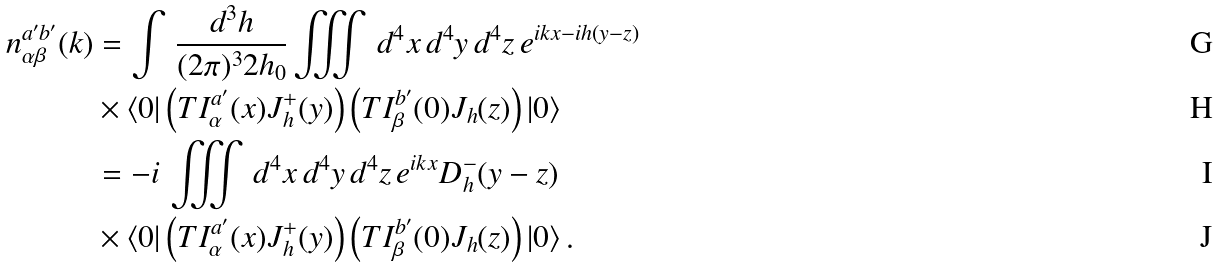Convert formula to latex. <formula><loc_0><loc_0><loc_500><loc_500>n ^ { a ^ { \prime } b ^ { \prime } } _ { \alpha \beta } ( k ) & = \int \, \frac { d ^ { 3 } h } { ( 2 \pi ) ^ { 3 } 2 h _ { 0 } } \iiint \, d ^ { 4 } x \, d ^ { 4 } y \, d ^ { 4 } z \, e ^ { i k x - i h ( y - z ) } \\ & \times \langle 0 | \left ( T I _ { \alpha } ^ { a ^ { \prime } } ( x ) J _ { h } ^ { + } ( y ) \right ) \left ( T I _ { \beta } ^ { b ^ { \prime } } ( 0 ) J _ { h } ( z ) \right ) | 0 \rangle \\ & = - i \, \iiint \, d ^ { 4 } x \, d ^ { 4 } y \, d ^ { 4 } z \, e ^ { i k x } D _ { h } ^ { - } ( y - z ) \\ & \times \langle 0 | \left ( T I _ { \alpha } ^ { a ^ { \prime } } ( x ) J _ { h } ^ { + } ( y ) \right ) \left ( T I _ { \beta } ^ { b ^ { \prime } } ( 0 ) J _ { h } ( z ) \right ) | 0 \rangle \, .</formula> 